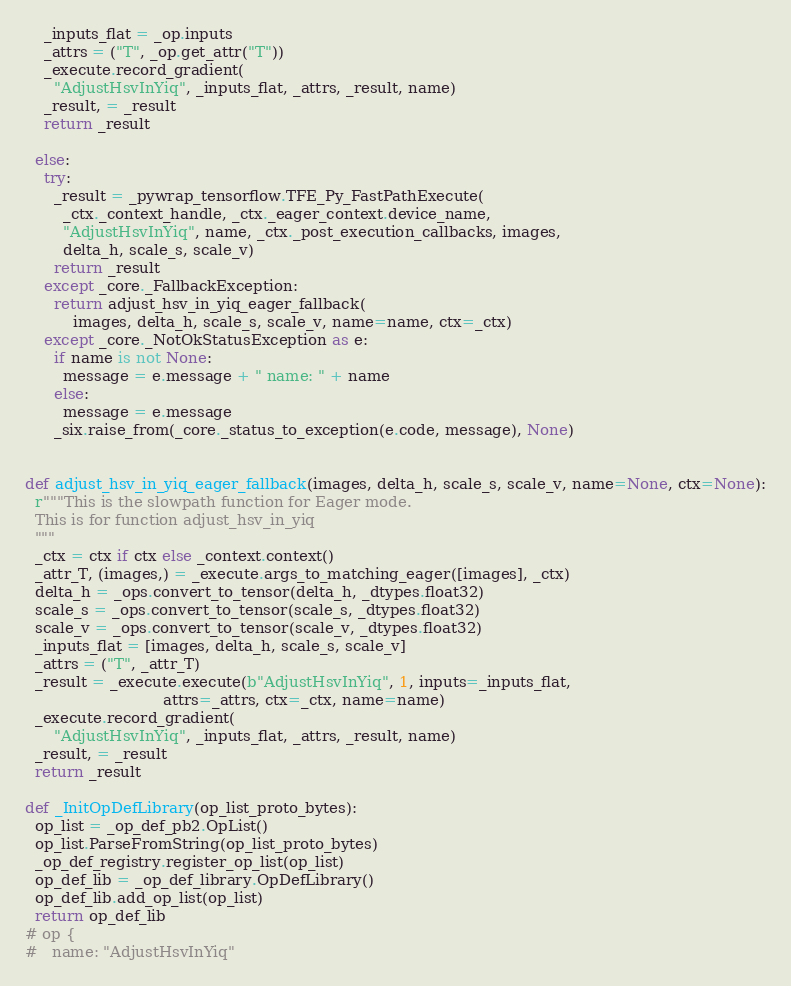<code> <loc_0><loc_0><loc_500><loc_500><_Python_>    _inputs_flat = _op.inputs
    _attrs = ("T", _op.get_attr("T"))
    _execute.record_gradient(
      "AdjustHsvInYiq", _inputs_flat, _attrs, _result, name)
    _result, = _result
    return _result

  else:
    try:
      _result = _pywrap_tensorflow.TFE_Py_FastPathExecute(
        _ctx._context_handle, _ctx._eager_context.device_name,
        "AdjustHsvInYiq", name, _ctx._post_execution_callbacks, images,
        delta_h, scale_s, scale_v)
      return _result
    except _core._FallbackException:
      return adjust_hsv_in_yiq_eager_fallback(
          images, delta_h, scale_s, scale_v, name=name, ctx=_ctx)
    except _core._NotOkStatusException as e:
      if name is not None:
        message = e.message + " name: " + name
      else:
        message = e.message
      _six.raise_from(_core._status_to_exception(e.code, message), None)


def adjust_hsv_in_yiq_eager_fallback(images, delta_h, scale_s, scale_v, name=None, ctx=None):
  r"""This is the slowpath function for Eager mode.
  This is for function adjust_hsv_in_yiq
  """
  _ctx = ctx if ctx else _context.context()
  _attr_T, (images,) = _execute.args_to_matching_eager([images], _ctx)
  delta_h = _ops.convert_to_tensor(delta_h, _dtypes.float32)
  scale_s = _ops.convert_to_tensor(scale_s, _dtypes.float32)
  scale_v = _ops.convert_to_tensor(scale_v, _dtypes.float32)
  _inputs_flat = [images, delta_h, scale_s, scale_v]
  _attrs = ("T", _attr_T)
  _result = _execute.execute(b"AdjustHsvInYiq", 1, inputs=_inputs_flat,
                             attrs=_attrs, ctx=_ctx, name=name)
  _execute.record_gradient(
      "AdjustHsvInYiq", _inputs_flat, _attrs, _result, name)
  _result, = _result
  return _result

def _InitOpDefLibrary(op_list_proto_bytes):
  op_list = _op_def_pb2.OpList()
  op_list.ParseFromString(op_list_proto_bytes)
  _op_def_registry.register_op_list(op_list)
  op_def_lib = _op_def_library.OpDefLibrary()
  op_def_lib.add_op_list(op_list)
  return op_def_lib
# op {
#   name: "AdjustHsvInYiq"</code> 